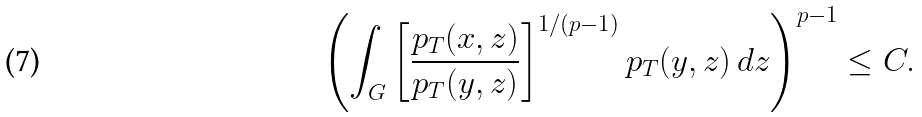Convert formula to latex. <formula><loc_0><loc_0><loc_500><loc_500>\left ( \int _ { G } \left [ \frac { p _ { T } ( x , z ) } { p _ { T } ( y , z ) } \right ] ^ { 1 / ( p - 1 ) } p _ { T } ( y , z ) \, d z \right ) ^ { p - 1 } \leq C .</formula> 